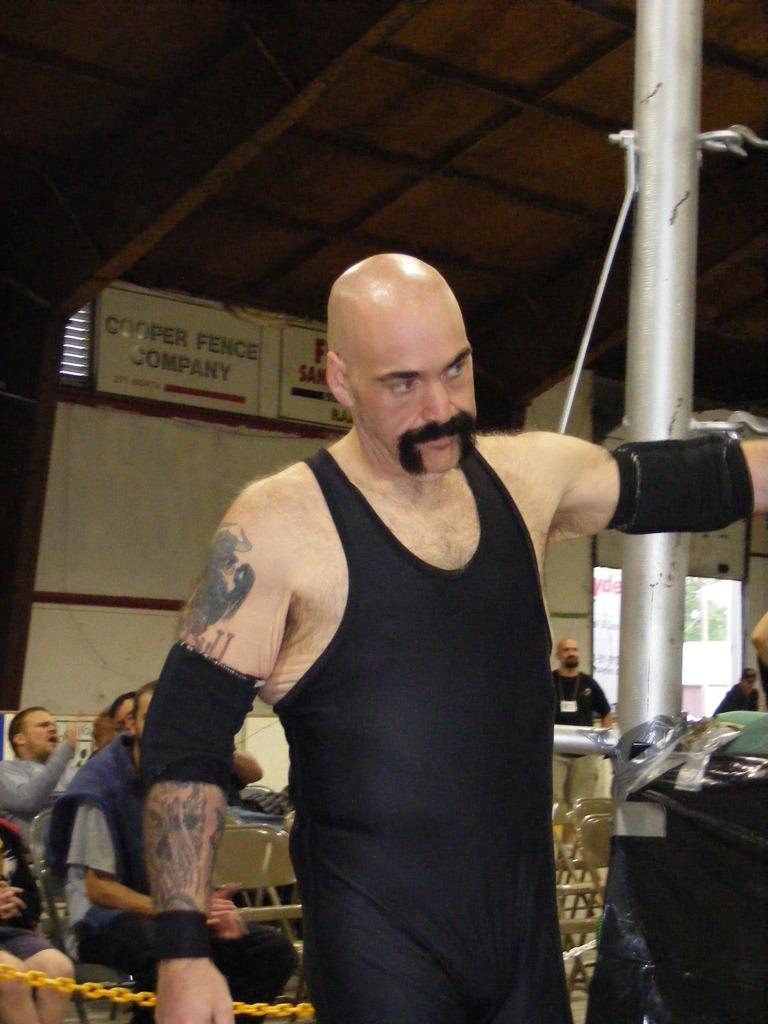Can you describe this image briefly? In this image I can see the group of people with different color dresses. I can see few people are sitting on the chairs and few people are standing. To the side I can see the chain and the pole. In the background I can see the boards and the roof. 